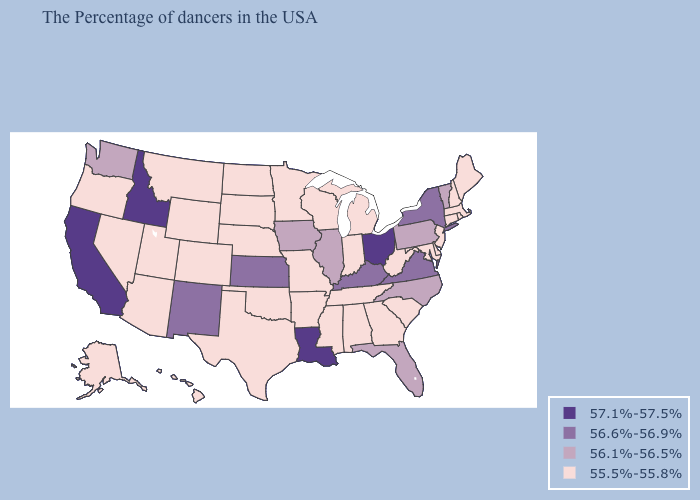Does Indiana have a lower value than Missouri?
Answer briefly. No. What is the lowest value in the West?
Concise answer only. 55.5%-55.8%. Does Nebraska have the same value as Mississippi?
Quick response, please. Yes. Does Oregon have a lower value than Tennessee?
Be succinct. No. What is the value of Arkansas?
Keep it brief. 55.5%-55.8%. Name the states that have a value in the range 55.5%-55.8%?
Write a very short answer. Maine, Massachusetts, Rhode Island, New Hampshire, Connecticut, New Jersey, Delaware, Maryland, South Carolina, West Virginia, Georgia, Michigan, Indiana, Alabama, Tennessee, Wisconsin, Mississippi, Missouri, Arkansas, Minnesota, Nebraska, Oklahoma, Texas, South Dakota, North Dakota, Wyoming, Colorado, Utah, Montana, Arizona, Nevada, Oregon, Alaska, Hawaii. Which states have the lowest value in the USA?
Answer briefly. Maine, Massachusetts, Rhode Island, New Hampshire, Connecticut, New Jersey, Delaware, Maryland, South Carolina, West Virginia, Georgia, Michigan, Indiana, Alabama, Tennessee, Wisconsin, Mississippi, Missouri, Arkansas, Minnesota, Nebraska, Oklahoma, Texas, South Dakota, North Dakota, Wyoming, Colorado, Utah, Montana, Arizona, Nevada, Oregon, Alaska, Hawaii. What is the value of Connecticut?
Short answer required. 55.5%-55.8%. What is the value of Missouri?
Keep it brief. 55.5%-55.8%. Which states hav the highest value in the South?
Write a very short answer. Louisiana. Among the states that border Massachusetts , does New York have the highest value?
Short answer required. Yes. Name the states that have a value in the range 56.1%-56.5%?
Answer briefly. Vermont, Pennsylvania, North Carolina, Florida, Illinois, Iowa, Washington. What is the value of Colorado?
Be succinct. 55.5%-55.8%. Does New Mexico have the lowest value in the West?
Be succinct. No. 